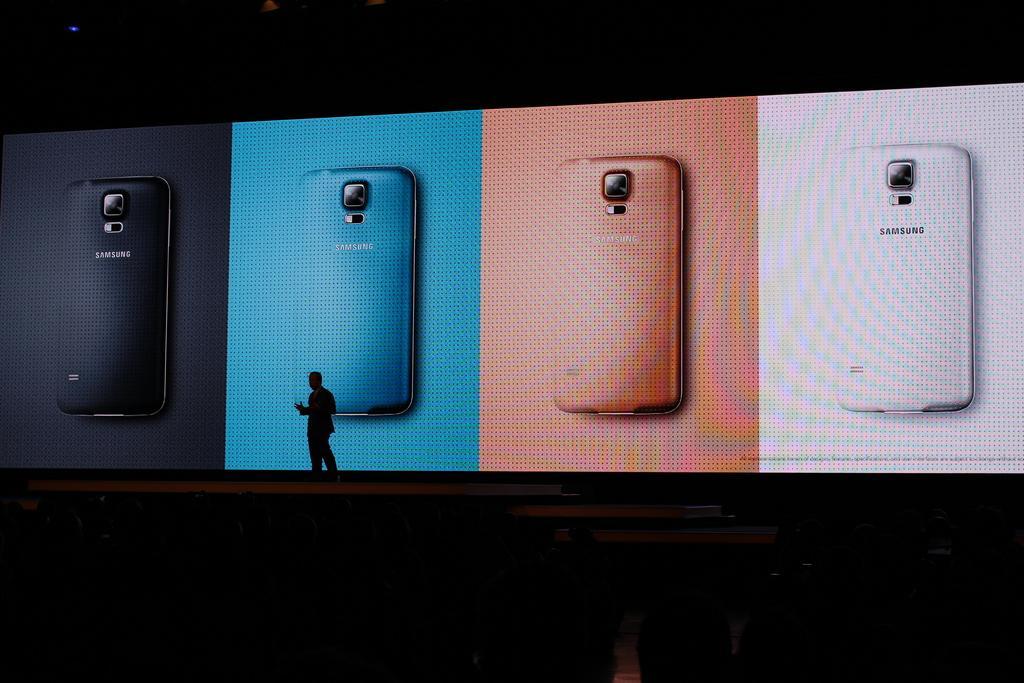Please provide a concise description of this image. In the foreground of this dark image, there is a man standing on the stage. Behind him, there is a big screen and a light at the top. 